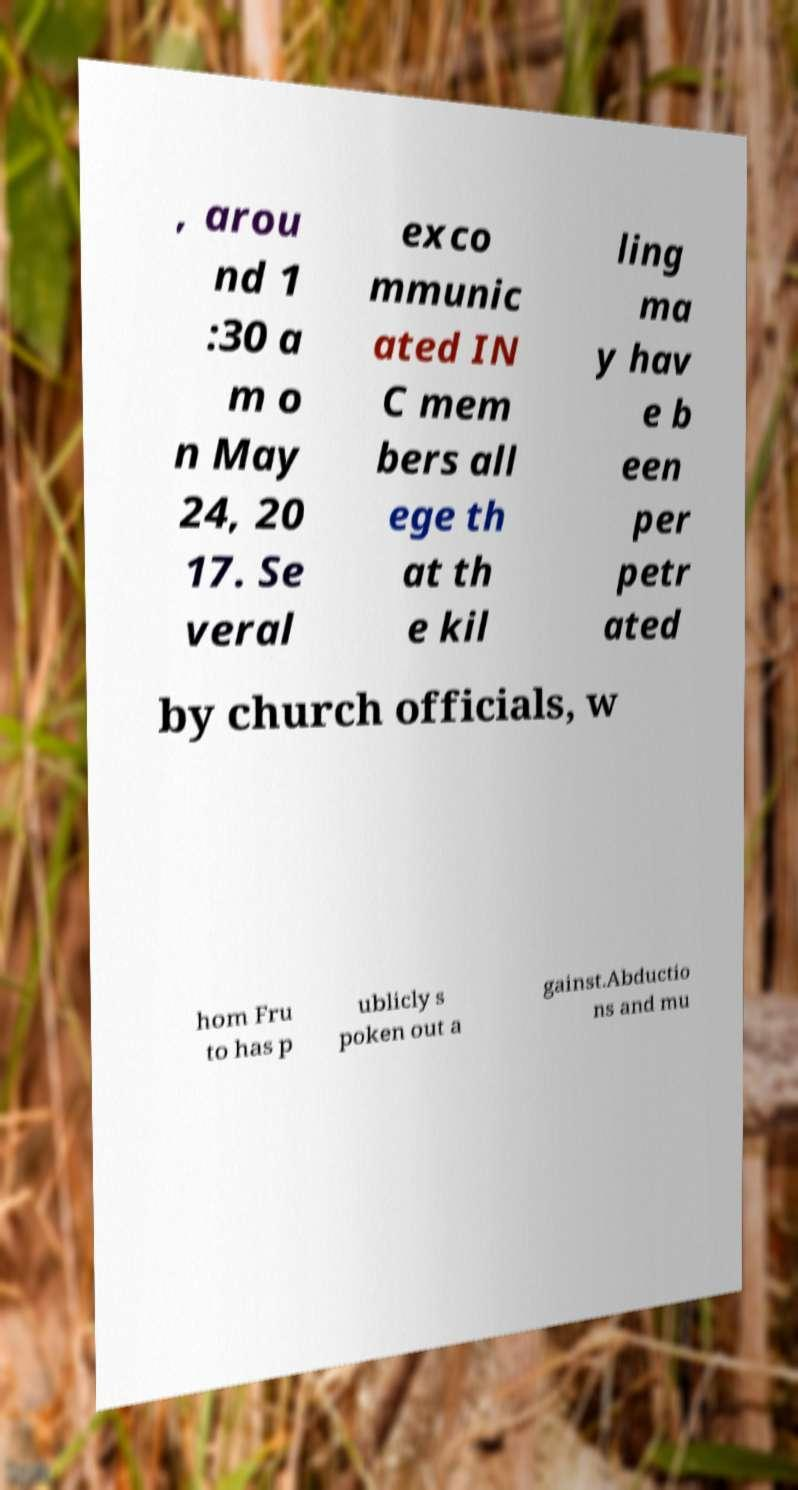Could you assist in decoding the text presented in this image and type it out clearly? , arou nd 1 :30 a m o n May 24, 20 17. Se veral exco mmunic ated IN C mem bers all ege th at th e kil ling ma y hav e b een per petr ated by church officials, w hom Fru to has p ublicly s poken out a gainst.Abductio ns and mu 